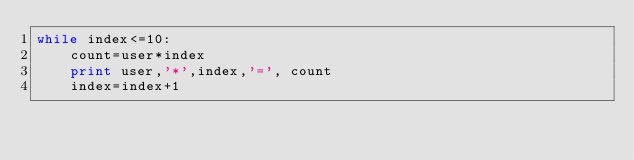<code> <loc_0><loc_0><loc_500><loc_500><_Python_>while index<=10:
	count=user*index
	print user,'*',index,'=', count
	index=index+1
</code> 